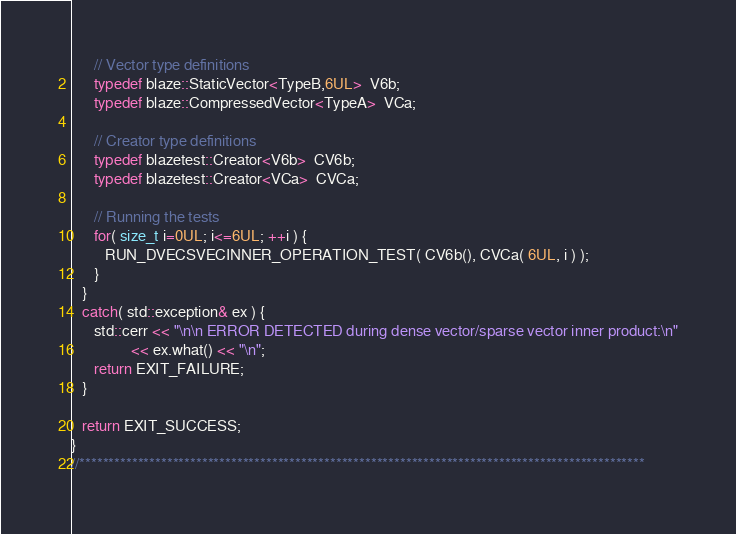<code> <loc_0><loc_0><loc_500><loc_500><_C++_>      // Vector type definitions
      typedef blaze::StaticVector<TypeB,6UL>  V6b;
      typedef blaze::CompressedVector<TypeA>  VCa;

      // Creator type definitions
      typedef blazetest::Creator<V6b>  CV6b;
      typedef blazetest::Creator<VCa>  CVCa;

      // Running the tests
      for( size_t i=0UL; i<=6UL; ++i ) {
         RUN_DVECSVECINNER_OPERATION_TEST( CV6b(), CVCa( 6UL, i ) );
      }
   }
   catch( std::exception& ex ) {
      std::cerr << "\n\n ERROR DETECTED during dense vector/sparse vector inner product:\n"
                << ex.what() << "\n";
      return EXIT_FAILURE;
   }

   return EXIT_SUCCESS;
}
//*************************************************************************************************
</code> 